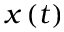Convert formula to latex. <formula><loc_0><loc_0><loc_500><loc_500>x \left ( t \right )</formula> 